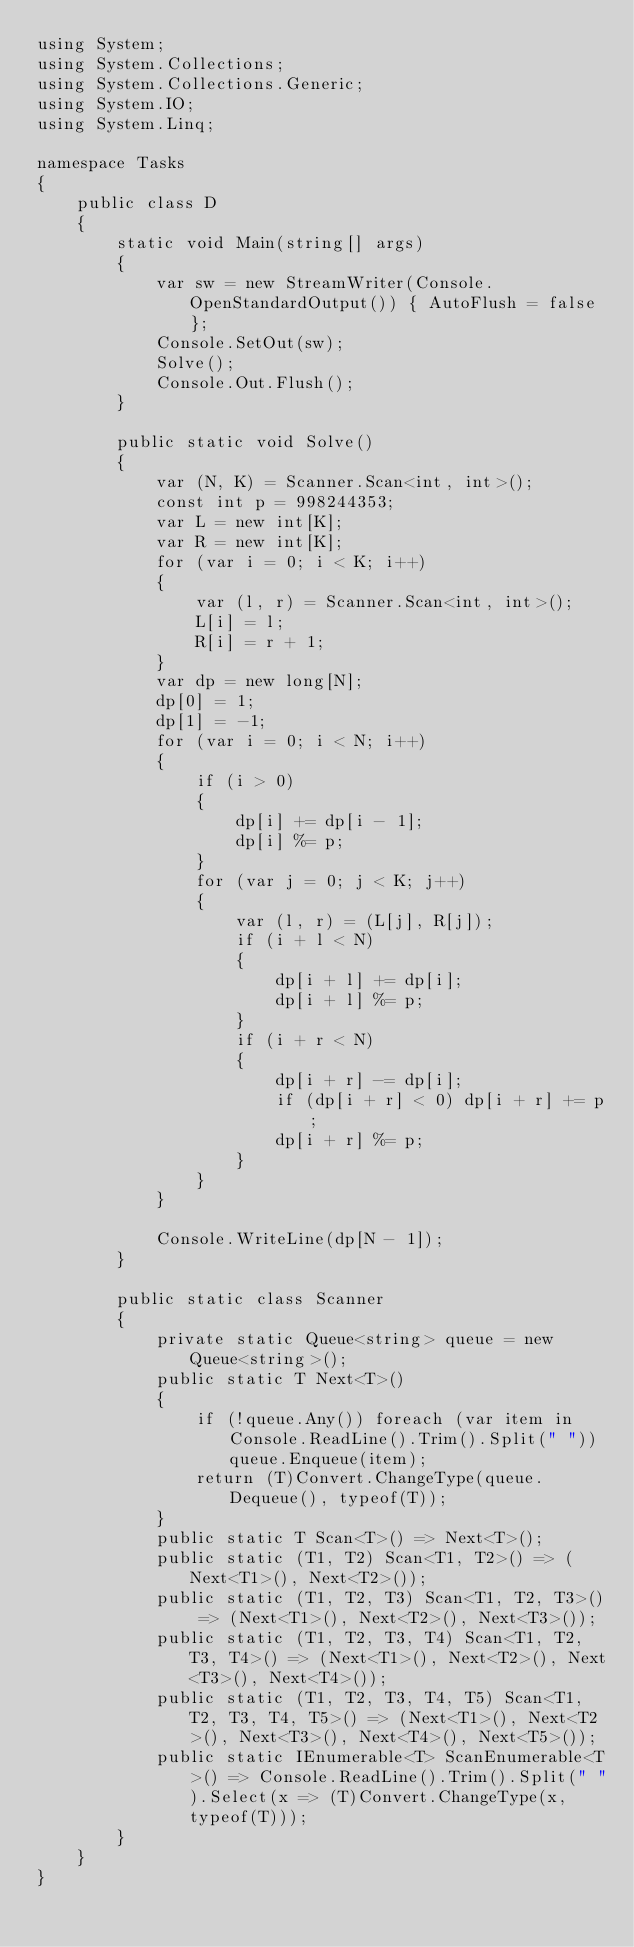Convert code to text. <code><loc_0><loc_0><loc_500><loc_500><_C#_>using System;
using System.Collections;
using System.Collections.Generic;
using System.IO;
using System.Linq;

namespace Tasks
{
    public class D
    {
        static void Main(string[] args)
        {
            var sw = new StreamWriter(Console.OpenStandardOutput()) { AutoFlush = false };
            Console.SetOut(sw);
            Solve();
            Console.Out.Flush();
        }

        public static void Solve()
        {
            var (N, K) = Scanner.Scan<int, int>();
            const int p = 998244353;
            var L = new int[K];
            var R = new int[K];
            for (var i = 0; i < K; i++)
            {
                var (l, r) = Scanner.Scan<int, int>();
                L[i] = l;
                R[i] = r + 1;
            }
            var dp = new long[N];
            dp[0] = 1;
            dp[1] = -1;
            for (var i = 0; i < N; i++)
            {
                if (i > 0)
                {
                    dp[i] += dp[i - 1];
                    dp[i] %= p;
                }
                for (var j = 0; j < K; j++)
                {
                    var (l, r) = (L[j], R[j]);
                    if (i + l < N)
                    {
                        dp[i + l] += dp[i];
                        dp[i + l] %= p;
                    }
                    if (i + r < N)
                    {
                        dp[i + r] -= dp[i];
                        if (dp[i + r] < 0) dp[i + r] += p;
                        dp[i + r] %= p;
                    }
                }
            }

            Console.WriteLine(dp[N - 1]);
        }

        public static class Scanner
        {
            private static Queue<string> queue = new Queue<string>();
            public static T Next<T>()
            {
                if (!queue.Any()) foreach (var item in Console.ReadLine().Trim().Split(" ")) queue.Enqueue(item);
                return (T)Convert.ChangeType(queue.Dequeue(), typeof(T));
            }
            public static T Scan<T>() => Next<T>();
            public static (T1, T2) Scan<T1, T2>() => (Next<T1>(), Next<T2>());
            public static (T1, T2, T3) Scan<T1, T2, T3>() => (Next<T1>(), Next<T2>(), Next<T3>());
            public static (T1, T2, T3, T4) Scan<T1, T2, T3, T4>() => (Next<T1>(), Next<T2>(), Next<T3>(), Next<T4>());
            public static (T1, T2, T3, T4, T5) Scan<T1, T2, T3, T4, T5>() => (Next<T1>(), Next<T2>(), Next<T3>(), Next<T4>(), Next<T5>());
            public static IEnumerable<T> ScanEnumerable<T>() => Console.ReadLine().Trim().Split(" ").Select(x => (T)Convert.ChangeType(x, typeof(T)));
        }
    }
}
</code> 